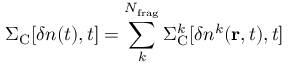Convert formula to latex. <formula><loc_0><loc_0><loc_500><loc_500>\Sigma _ { C } [ \delta n ( t ) , t ] = \sum _ { k } ^ { N _ { f r a g } } \Sigma _ { C } ^ { k } [ \delta n ^ { k } ( { r } , t ) , t ]</formula> 